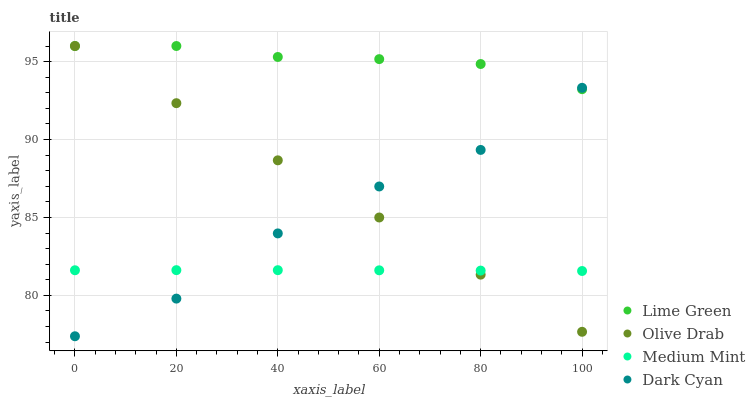Does Medium Mint have the minimum area under the curve?
Answer yes or no. Yes. Does Lime Green have the maximum area under the curve?
Answer yes or no. Yes. Does Dark Cyan have the minimum area under the curve?
Answer yes or no. No. Does Dark Cyan have the maximum area under the curve?
Answer yes or no. No. Is Olive Drab the smoothest?
Answer yes or no. Yes. Is Dark Cyan the roughest?
Answer yes or no. Yes. Is Lime Green the smoothest?
Answer yes or no. No. Is Lime Green the roughest?
Answer yes or no. No. Does Dark Cyan have the lowest value?
Answer yes or no. Yes. Does Lime Green have the lowest value?
Answer yes or no. No. Does Olive Drab have the highest value?
Answer yes or no. Yes. Does Dark Cyan have the highest value?
Answer yes or no. No. Is Medium Mint less than Lime Green?
Answer yes or no. Yes. Is Lime Green greater than Medium Mint?
Answer yes or no. Yes. Does Olive Drab intersect Dark Cyan?
Answer yes or no. Yes. Is Olive Drab less than Dark Cyan?
Answer yes or no. No. Is Olive Drab greater than Dark Cyan?
Answer yes or no. No. Does Medium Mint intersect Lime Green?
Answer yes or no. No. 